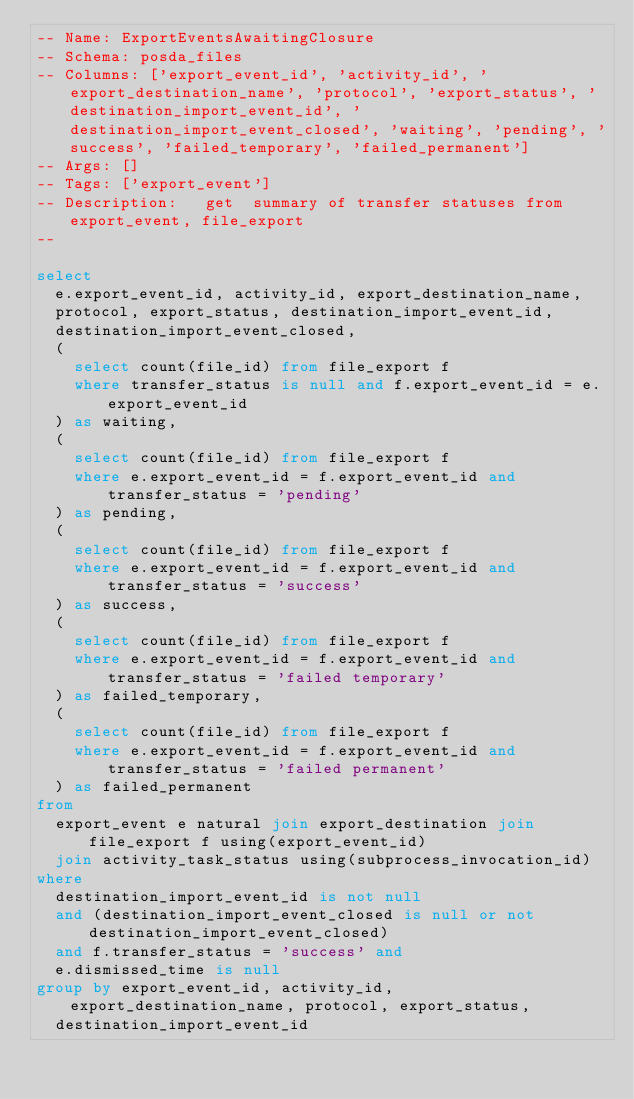<code> <loc_0><loc_0><loc_500><loc_500><_SQL_>-- Name: ExportEventsAwaitingClosure
-- Schema: posda_files
-- Columns: ['export_event_id', 'activity_id', 'export_destination_name', 'protocol', 'export_status', 'destination_import_event_id', 'destination_import_event_closed', 'waiting', 'pending', 'success', 'failed_temporary', 'failed_permanent']
-- Args: []
-- Tags: ['export_event']
-- Description:   get  summary of transfer statuses from export_event, file_export
--

select
  e.export_event_id, activity_id, export_destination_name, 
  protocol, export_status, destination_import_event_id,
  destination_import_event_closed,
  (
    select count(file_id) from file_export f 
    where transfer_status is null and f.export_event_id = e.export_event_id
  ) as waiting,
  (
    select count(file_id) from file_export f
    where e.export_event_id = f.export_event_id and transfer_status = 'pending'
  ) as pending,
  (
    select count(file_id) from file_export f
    where e.export_event_id = f.export_event_id and transfer_status = 'success'
  ) as success,
  (
    select count(file_id) from file_export f
    where e.export_event_id = f.export_event_id and transfer_status = 'failed temporary'
  ) as failed_temporary,
  (
    select count(file_id) from file_export f
    where e.export_event_id = f.export_event_id and transfer_status = 'failed permanent'
  ) as failed_permanent
from
  export_event e natural join export_destination join file_export f using(export_event_id)
  join activity_task_status using(subprocess_invocation_id)
where
  destination_import_event_id is not null
  and (destination_import_event_closed is null or not destination_import_event_closed)
  and f.transfer_status = 'success' and
  e.dismissed_time is null
group by export_event_id, activity_id, export_destination_name, protocol, export_status,
  destination_import_event_id</code> 